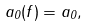<formula> <loc_0><loc_0><loc_500><loc_500>a _ { 0 } ( f ) = a _ { 0 } ,</formula> 